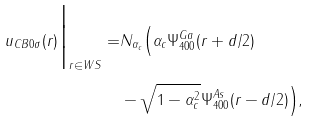Convert formula to latex. <formula><loc_0><loc_0><loc_500><loc_500>u _ { C B 0 \sigma } ( r ) \Big | _ { r \in W S } = & N _ { \alpha _ { c } } \Big ( \alpha _ { c } \Psi _ { 4 0 0 } ^ { G a } ( r + d / 2 ) \\ & - \sqrt { 1 - \alpha _ { c } ^ { 2 } } \Psi _ { 4 0 0 } ^ { A s } ( r - d / 2 ) \Big ) ,</formula> 